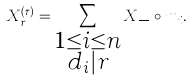<formula> <loc_0><loc_0><loc_500><loc_500>X _ { r } ^ { ( \tau ) } = \sum _ { \substack { 1 \leq i \leq n \\ d _ { i } | r } } X _ { \frac { r } { d _ { i } } } \circ m _ { i } .</formula> 